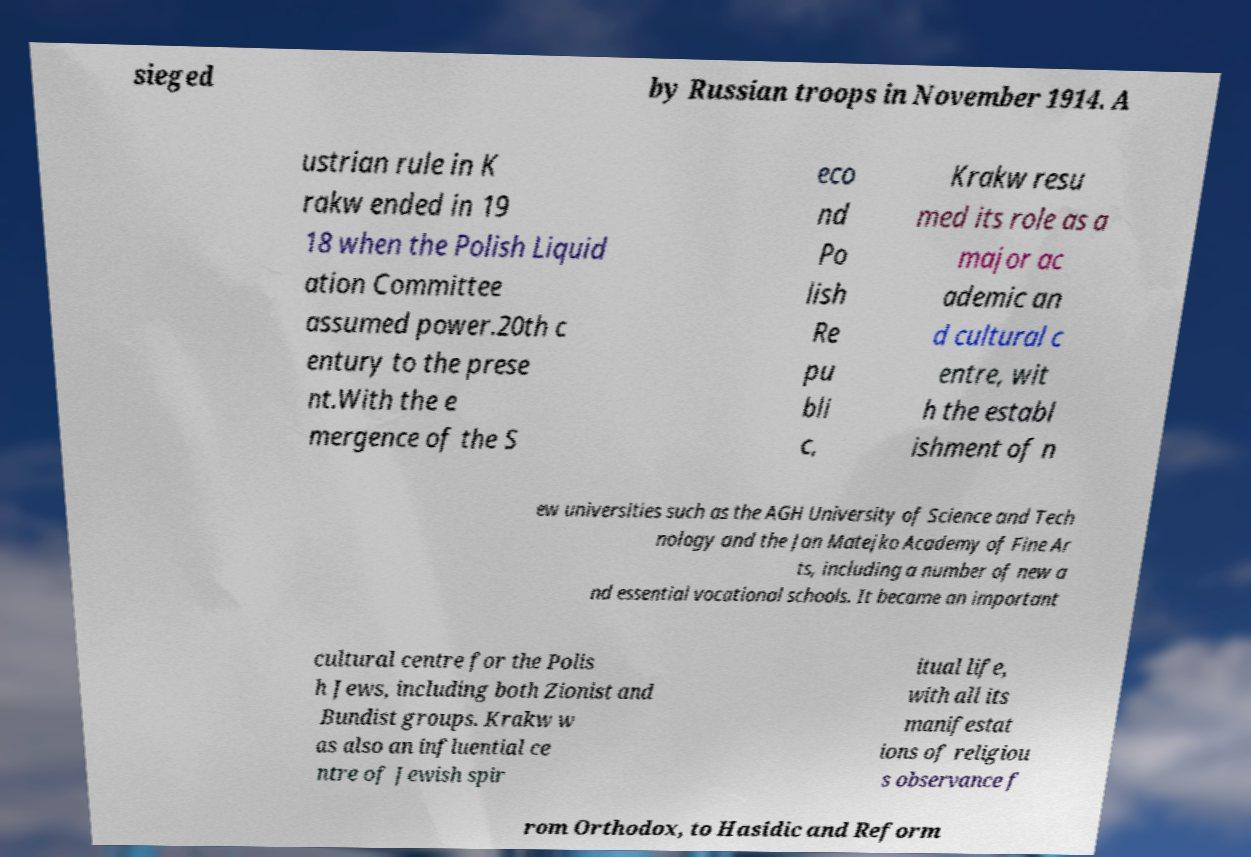Can you accurately transcribe the text from the provided image for me? sieged by Russian troops in November 1914. A ustrian rule in K rakw ended in 19 18 when the Polish Liquid ation Committee assumed power.20th c entury to the prese nt.With the e mergence of the S eco nd Po lish Re pu bli c, Krakw resu med its role as a major ac ademic an d cultural c entre, wit h the establ ishment of n ew universities such as the AGH University of Science and Tech nology and the Jan Matejko Academy of Fine Ar ts, including a number of new a nd essential vocational schools. It became an important cultural centre for the Polis h Jews, including both Zionist and Bundist groups. Krakw w as also an influential ce ntre of Jewish spir itual life, with all its manifestat ions of religiou s observance f rom Orthodox, to Hasidic and Reform 